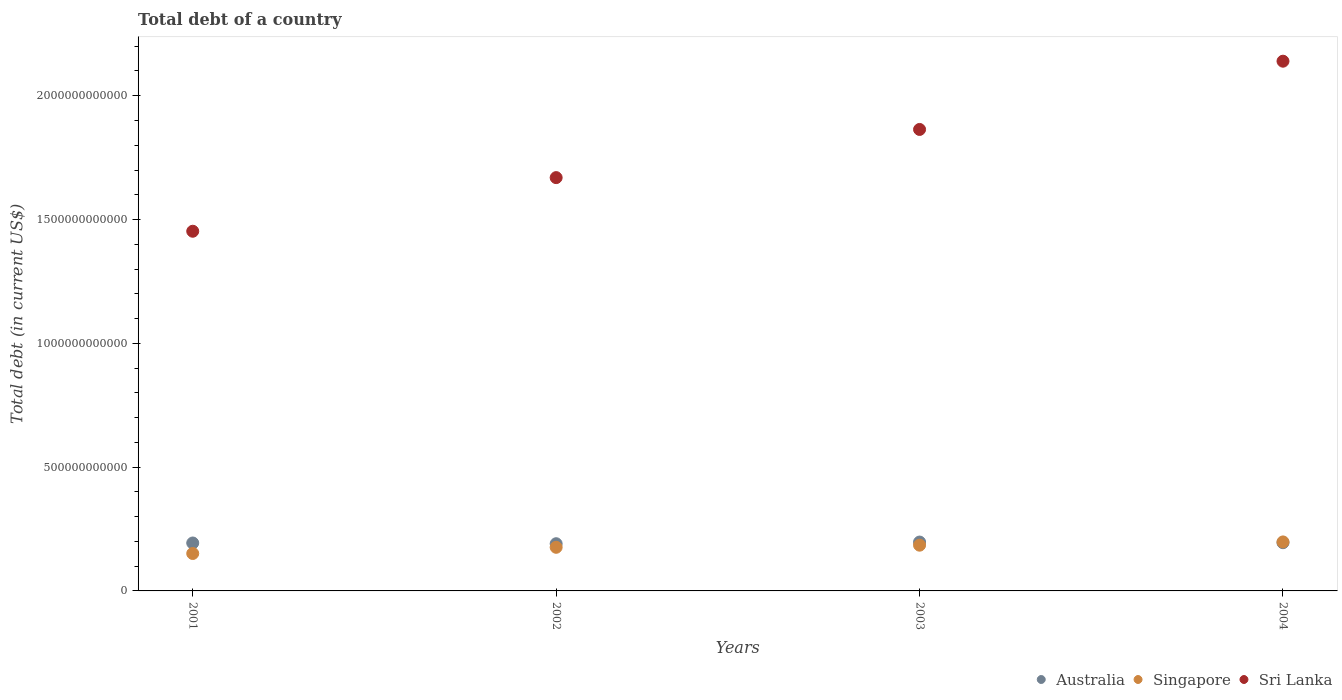Is the number of dotlines equal to the number of legend labels?
Ensure brevity in your answer.  Yes. What is the debt in Sri Lanka in 2002?
Your answer should be compact. 1.67e+12. Across all years, what is the maximum debt in Sri Lanka?
Your answer should be compact. 2.14e+12. Across all years, what is the minimum debt in Sri Lanka?
Offer a terse response. 1.45e+12. What is the total debt in Australia in the graph?
Keep it short and to the point. 7.76e+11. What is the difference between the debt in Australia in 2001 and that in 2003?
Your answer should be compact. -3.81e+09. What is the difference between the debt in Sri Lanka in 2002 and the debt in Australia in 2001?
Offer a very short reply. 1.48e+12. What is the average debt in Australia per year?
Offer a very short reply. 1.94e+11. In the year 2004, what is the difference between the debt in Sri Lanka and debt in Australia?
Give a very brief answer. 1.94e+12. What is the ratio of the debt in Sri Lanka in 2001 to that in 2002?
Your response must be concise. 0.87. Is the debt in Sri Lanka in 2001 less than that in 2004?
Make the answer very short. Yes. Is the difference between the debt in Sri Lanka in 2003 and 2004 greater than the difference between the debt in Australia in 2003 and 2004?
Keep it short and to the point. No. What is the difference between the highest and the second highest debt in Australia?
Provide a short and direct response. 2.69e+09. What is the difference between the highest and the lowest debt in Singapore?
Offer a very short reply. 4.68e+1. Does the debt in Sri Lanka monotonically increase over the years?
Give a very brief answer. Yes. Is the debt in Singapore strictly less than the debt in Australia over the years?
Give a very brief answer. No. How many dotlines are there?
Provide a succinct answer. 3. How many years are there in the graph?
Give a very brief answer. 4. What is the difference between two consecutive major ticks on the Y-axis?
Your response must be concise. 5.00e+11. Where does the legend appear in the graph?
Your answer should be very brief. Bottom right. How many legend labels are there?
Ensure brevity in your answer.  3. What is the title of the graph?
Your response must be concise. Total debt of a country. Does "Malawi" appear as one of the legend labels in the graph?
Make the answer very short. No. What is the label or title of the X-axis?
Give a very brief answer. Years. What is the label or title of the Y-axis?
Your answer should be compact. Total debt (in current US$). What is the Total debt (in current US$) of Australia in 2001?
Your answer should be very brief. 1.94e+11. What is the Total debt (in current US$) in Singapore in 2001?
Your response must be concise. 1.51e+11. What is the Total debt (in current US$) in Sri Lanka in 2001?
Provide a succinct answer. 1.45e+12. What is the Total debt (in current US$) in Australia in 2002?
Ensure brevity in your answer.  1.91e+11. What is the Total debt (in current US$) of Singapore in 2002?
Offer a very short reply. 1.76e+11. What is the Total debt (in current US$) of Sri Lanka in 2002?
Give a very brief answer. 1.67e+12. What is the Total debt (in current US$) in Australia in 2003?
Offer a very short reply. 1.97e+11. What is the Total debt (in current US$) in Singapore in 2003?
Offer a very short reply. 1.85e+11. What is the Total debt (in current US$) of Sri Lanka in 2003?
Your response must be concise. 1.86e+12. What is the Total debt (in current US$) of Australia in 2004?
Your answer should be very brief. 1.95e+11. What is the Total debt (in current US$) in Singapore in 2004?
Offer a very short reply. 1.98e+11. What is the Total debt (in current US$) of Sri Lanka in 2004?
Offer a terse response. 2.14e+12. Across all years, what is the maximum Total debt (in current US$) of Australia?
Give a very brief answer. 1.97e+11. Across all years, what is the maximum Total debt (in current US$) of Singapore?
Provide a short and direct response. 1.98e+11. Across all years, what is the maximum Total debt (in current US$) of Sri Lanka?
Make the answer very short. 2.14e+12. Across all years, what is the minimum Total debt (in current US$) in Australia?
Provide a short and direct response. 1.91e+11. Across all years, what is the minimum Total debt (in current US$) of Singapore?
Give a very brief answer. 1.51e+11. Across all years, what is the minimum Total debt (in current US$) of Sri Lanka?
Your answer should be compact. 1.45e+12. What is the total Total debt (in current US$) of Australia in the graph?
Give a very brief answer. 7.76e+11. What is the total Total debt (in current US$) in Singapore in the graph?
Offer a very short reply. 7.10e+11. What is the total Total debt (in current US$) in Sri Lanka in the graph?
Keep it short and to the point. 7.13e+12. What is the difference between the Total debt (in current US$) of Australia in 2001 and that in 2002?
Your response must be concise. 2.95e+09. What is the difference between the Total debt (in current US$) of Singapore in 2001 and that in 2002?
Offer a terse response. -2.51e+1. What is the difference between the Total debt (in current US$) in Sri Lanka in 2001 and that in 2002?
Your answer should be very brief. -2.17e+11. What is the difference between the Total debt (in current US$) in Australia in 2001 and that in 2003?
Give a very brief answer. -3.81e+09. What is the difference between the Total debt (in current US$) of Singapore in 2001 and that in 2003?
Your response must be concise. -3.36e+1. What is the difference between the Total debt (in current US$) of Sri Lanka in 2001 and that in 2003?
Make the answer very short. -4.11e+11. What is the difference between the Total debt (in current US$) in Australia in 2001 and that in 2004?
Ensure brevity in your answer.  -1.13e+09. What is the difference between the Total debt (in current US$) in Singapore in 2001 and that in 2004?
Offer a terse response. -4.68e+1. What is the difference between the Total debt (in current US$) in Sri Lanka in 2001 and that in 2004?
Offer a very short reply. -6.87e+11. What is the difference between the Total debt (in current US$) in Australia in 2002 and that in 2003?
Provide a succinct answer. -6.76e+09. What is the difference between the Total debt (in current US$) in Singapore in 2002 and that in 2003?
Offer a very short reply. -8.54e+09. What is the difference between the Total debt (in current US$) in Sri Lanka in 2002 and that in 2003?
Provide a succinct answer. -1.95e+11. What is the difference between the Total debt (in current US$) of Australia in 2002 and that in 2004?
Make the answer very short. -4.08e+09. What is the difference between the Total debt (in current US$) of Singapore in 2002 and that in 2004?
Give a very brief answer. -2.17e+1. What is the difference between the Total debt (in current US$) of Sri Lanka in 2002 and that in 2004?
Keep it short and to the point. -4.70e+11. What is the difference between the Total debt (in current US$) in Australia in 2003 and that in 2004?
Provide a succinct answer. 2.69e+09. What is the difference between the Total debt (in current US$) of Singapore in 2003 and that in 2004?
Provide a succinct answer. -1.32e+1. What is the difference between the Total debt (in current US$) in Sri Lanka in 2003 and that in 2004?
Ensure brevity in your answer.  -2.76e+11. What is the difference between the Total debt (in current US$) of Australia in 2001 and the Total debt (in current US$) of Singapore in 2002?
Provide a short and direct response. 1.74e+1. What is the difference between the Total debt (in current US$) in Australia in 2001 and the Total debt (in current US$) in Sri Lanka in 2002?
Your answer should be very brief. -1.48e+12. What is the difference between the Total debt (in current US$) of Singapore in 2001 and the Total debt (in current US$) of Sri Lanka in 2002?
Provide a succinct answer. -1.52e+12. What is the difference between the Total debt (in current US$) of Australia in 2001 and the Total debt (in current US$) of Singapore in 2003?
Make the answer very short. 8.85e+09. What is the difference between the Total debt (in current US$) in Australia in 2001 and the Total debt (in current US$) in Sri Lanka in 2003?
Your response must be concise. -1.67e+12. What is the difference between the Total debt (in current US$) in Singapore in 2001 and the Total debt (in current US$) in Sri Lanka in 2003?
Provide a succinct answer. -1.71e+12. What is the difference between the Total debt (in current US$) in Australia in 2001 and the Total debt (in current US$) in Singapore in 2004?
Offer a very short reply. -4.31e+09. What is the difference between the Total debt (in current US$) in Australia in 2001 and the Total debt (in current US$) in Sri Lanka in 2004?
Offer a very short reply. -1.95e+12. What is the difference between the Total debt (in current US$) in Singapore in 2001 and the Total debt (in current US$) in Sri Lanka in 2004?
Give a very brief answer. -1.99e+12. What is the difference between the Total debt (in current US$) in Australia in 2002 and the Total debt (in current US$) in Singapore in 2003?
Give a very brief answer. 5.90e+09. What is the difference between the Total debt (in current US$) in Australia in 2002 and the Total debt (in current US$) in Sri Lanka in 2003?
Your response must be concise. -1.67e+12. What is the difference between the Total debt (in current US$) of Singapore in 2002 and the Total debt (in current US$) of Sri Lanka in 2003?
Your answer should be very brief. -1.69e+12. What is the difference between the Total debt (in current US$) in Australia in 2002 and the Total debt (in current US$) in Singapore in 2004?
Your answer should be compact. -7.26e+09. What is the difference between the Total debt (in current US$) in Australia in 2002 and the Total debt (in current US$) in Sri Lanka in 2004?
Your response must be concise. -1.95e+12. What is the difference between the Total debt (in current US$) in Singapore in 2002 and the Total debt (in current US$) in Sri Lanka in 2004?
Give a very brief answer. -1.96e+12. What is the difference between the Total debt (in current US$) of Australia in 2003 and the Total debt (in current US$) of Singapore in 2004?
Provide a short and direct response. -4.97e+08. What is the difference between the Total debt (in current US$) of Australia in 2003 and the Total debt (in current US$) of Sri Lanka in 2004?
Keep it short and to the point. -1.94e+12. What is the difference between the Total debt (in current US$) of Singapore in 2003 and the Total debt (in current US$) of Sri Lanka in 2004?
Provide a succinct answer. -1.95e+12. What is the average Total debt (in current US$) in Australia per year?
Your response must be concise. 1.94e+11. What is the average Total debt (in current US$) of Singapore per year?
Give a very brief answer. 1.77e+11. What is the average Total debt (in current US$) of Sri Lanka per year?
Ensure brevity in your answer.  1.78e+12. In the year 2001, what is the difference between the Total debt (in current US$) of Australia and Total debt (in current US$) of Singapore?
Ensure brevity in your answer.  4.25e+1. In the year 2001, what is the difference between the Total debt (in current US$) in Australia and Total debt (in current US$) in Sri Lanka?
Keep it short and to the point. -1.26e+12. In the year 2001, what is the difference between the Total debt (in current US$) in Singapore and Total debt (in current US$) in Sri Lanka?
Your answer should be compact. -1.30e+12. In the year 2002, what is the difference between the Total debt (in current US$) in Australia and Total debt (in current US$) in Singapore?
Provide a succinct answer. 1.44e+1. In the year 2002, what is the difference between the Total debt (in current US$) in Australia and Total debt (in current US$) in Sri Lanka?
Offer a very short reply. -1.48e+12. In the year 2002, what is the difference between the Total debt (in current US$) of Singapore and Total debt (in current US$) of Sri Lanka?
Give a very brief answer. -1.49e+12. In the year 2003, what is the difference between the Total debt (in current US$) in Australia and Total debt (in current US$) in Singapore?
Keep it short and to the point. 1.27e+1. In the year 2003, what is the difference between the Total debt (in current US$) of Australia and Total debt (in current US$) of Sri Lanka?
Your answer should be compact. -1.67e+12. In the year 2003, what is the difference between the Total debt (in current US$) in Singapore and Total debt (in current US$) in Sri Lanka?
Offer a terse response. -1.68e+12. In the year 2004, what is the difference between the Total debt (in current US$) of Australia and Total debt (in current US$) of Singapore?
Keep it short and to the point. -3.18e+09. In the year 2004, what is the difference between the Total debt (in current US$) of Australia and Total debt (in current US$) of Sri Lanka?
Provide a short and direct response. -1.94e+12. In the year 2004, what is the difference between the Total debt (in current US$) of Singapore and Total debt (in current US$) of Sri Lanka?
Your response must be concise. -1.94e+12. What is the ratio of the Total debt (in current US$) in Australia in 2001 to that in 2002?
Offer a very short reply. 1.02. What is the ratio of the Total debt (in current US$) in Singapore in 2001 to that in 2002?
Make the answer very short. 0.86. What is the ratio of the Total debt (in current US$) in Sri Lanka in 2001 to that in 2002?
Ensure brevity in your answer.  0.87. What is the ratio of the Total debt (in current US$) of Australia in 2001 to that in 2003?
Your answer should be compact. 0.98. What is the ratio of the Total debt (in current US$) in Singapore in 2001 to that in 2003?
Offer a terse response. 0.82. What is the ratio of the Total debt (in current US$) of Sri Lanka in 2001 to that in 2003?
Make the answer very short. 0.78. What is the ratio of the Total debt (in current US$) in Australia in 2001 to that in 2004?
Offer a very short reply. 0.99. What is the ratio of the Total debt (in current US$) in Singapore in 2001 to that in 2004?
Keep it short and to the point. 0.76. What is the ratio of the Total debt (in current US$) of Sri Lanka in 2001 to that in 2004?
Provide a short and direct response. 0.68. What is the ratio of the Total debt (in current US$) in Australia in 2002 to that in 2003?
Offer a terse response. 0.97. What is the ratio of the Total debt (in current US$) in Singapore in 2002 to that in 2003?
Your answer should be very brief. 0.95. What is the ratio of the Total debt (in current US$) in Sri Lanka in 2002 to that in 2003?
Ensure brevity in your answer.  0.9. What is the ratio of the Total debt (in current US$) of Australia in 2002 to that in 2004?
Give a very brief answer. 0.98. What is the ratio of the Total debt (in current US$) in Singapore in 2002 to that in 2004?
Offer a terse response. 0.89. What is the ratio of the Total debt (in current US$) in Sri Lanka in 2002 to that in 2004?
Your answer should be very brief. 0.78. What is the ratio of the Total debt (in current US$) of Australia in 2003 to that in 2004?
Your answer should be compact. 1.01. What is the ratio of the Total debt (in current US$) in Singapore in 2003 to that in 2004?
Offer a very short reply. 0.93. What is the ratio of the Total debt (in current US$) in Sri Lanka in 2003 to that in 2004?
Your response must be concise. 0.87. What is the difference between the highest and the second highest Total debt (in current US$) in Australia?
Give a very brief answer. 2.69e+09. What is the difference between the highest and the second highest Total debt (in current US$) of Singapore?
Your answer should be compact. 1.32e+1. What is the difference between the highest and the second highest Total debt (in current US$) in Sri Lanka?
Provide a short and direct response. 2.76e+11. What is the difference between the highest and the lowest Total debt (in current US$) in Australia?
Provide a short and direct response. 6.76e+09. What is the difference between the highest and the lowest Total debt (in current US$) of Singapore?
Keep it short and to the point. 4.68e+1. What is the difference between the highest and the lowest Total debt (in current US$) of Sri Lanka?
Your answer should be compact. 6.87e+11. 